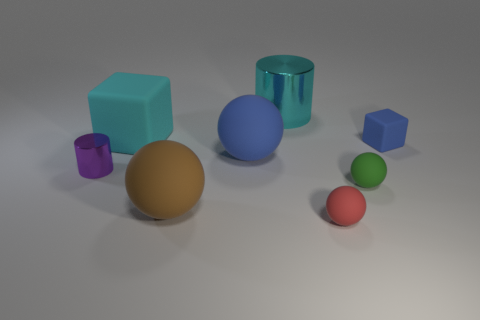Subtract 1 spheres. How many spheres are left? 3 Add 1 cyan shiny cylinders. How many objects exist? 9 Subtract all blocks. How many objects are left? 6 Add 2 brown matte things. How many brown matte things are left? 3 Add 6 tiny metal spheres. How many tiny metal spheres exist? 6 Subtract 1 cyan blocks. How many objects are left? 7 Subtract all gray cubes. Subtract all big blue spheres. How many objects are left? 7 